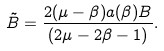Convert formula to latex. <formula><loc_0><loc_0><loc_500><loc_500>\tilde { B } = \frac { 2 ( \mu - \beta ) a ( \beta ) B } { ( 2 \mu - 2 \beta - 1 ) } .</formula> 